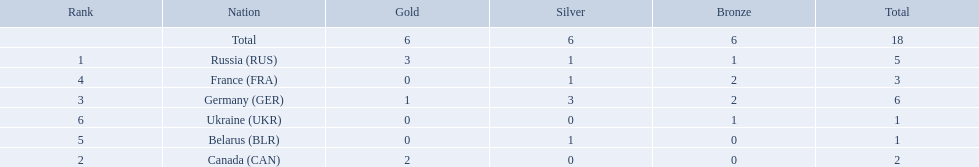Which nations participated? Russia (RUS), Canada (CAN), Germany (GER), France (FRA), Belarus (BLR), Ukraine (UKR). And how many gold medals did they win? 3, 2, 1, 0, 0, 0. What about silver medals? 1, 0, 3, 1, 1, 0. And bronze? 1, 0, 2, 2, 0, 1. Which nation only won gold medals? Canada (CAN). 